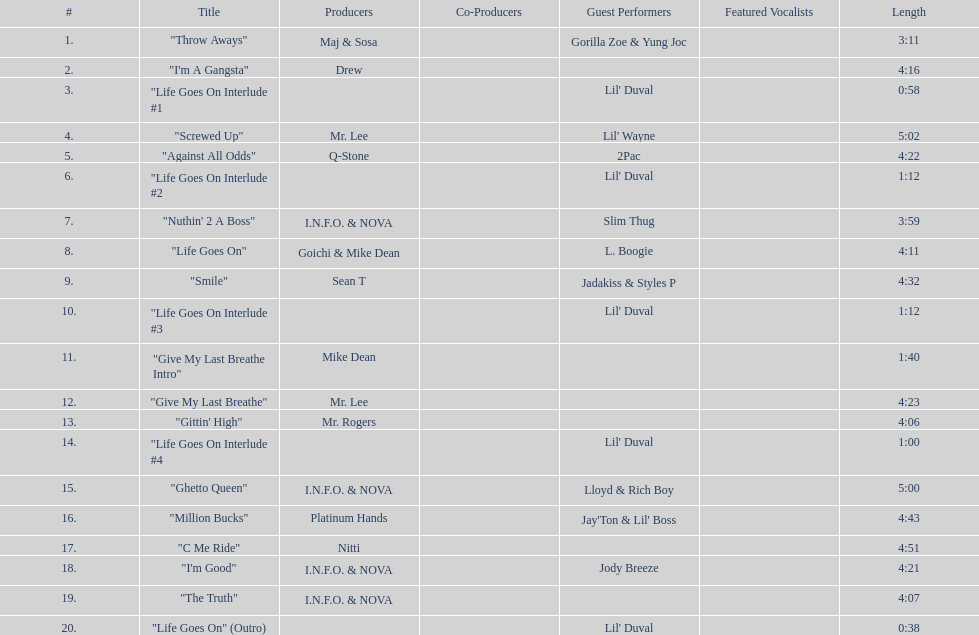I'm looking to parse the entire table for insights. Could you assist me with that? {'header': ['#', 'Title', 'Producers', 'Co-Producers', 'Guest Performers', 'Featured Vocalists', 'Length'], 'rows': [['1.', '"Throw Aways"', 'Maj & Sosa', '', 'Gorilla Zoe & Yung Joc', '', '3:11'], ['2.', '"I\'m A Gangsta"', 'Drew', '', '', '', '4:16'], ['3.', '"Life Goes On Interlude #1', '', '', "Lil' Duval", '', '0:58'], ['4.', '"Screwed Up"', 'Mr. Lee', '', "Lil' Wayne", '', '5:02'], ['5.', '"Against All Odds"', 'Q-Stone', '', '2Pac', '', '4:22'], ['6.', '"Life Goes On Interlude #2', '', '', "Lil' Duval", '', '1:12'], ['7.', '"Nuthin\' 2 A Boss"', 'I.N.F.O. & NOVA', '', 'Slim Thug', '', '3:59'], ['8.', '"Life Goes On"', 'Goichi & Mike Dean', '', 'L. Boogie', '', '4:11'], ['9.', '"Smile"', 'Sean T', '', 'Jadakiss & Styles P', '', '4:32'], ['10.', '"Life Goes On Interlude #3', '', '', "Lil' Duval", '', '1:12'], ['11.', '"Give My Last Breathe Intro"', 'Mike Dean', '', '', '', '1:40'], ['12.', '"Give My Last Breathe"', 'Mr. Lee', '', '', '', '4:23'], ['13.', '"Gittin\' High"', 'Mr. Rogers', '', '', '', '4:06'], ['14.', '"Life Goes On Interlude #4', '', '', "Lil' Duval", '', '1:00'], ['15.', '"Ghetto Queen"', 'I.N.F.O. & NOVA', '', 'Lloyd & Rich Boy', '', '5:00'], ['16.', '"Million Bucks"', 'Platinum Hands', '', "Jay'Ton & Lil' Boss", '', '4:43'], ['17.', '"C Me Ride"', 'Nitti', '', '', '', '4:51'], ['18.', '"I\'m Good"', 'I.N.F.O. & NOVA', '', 'Jody Breeze', '', '4:21'], ['19.', '"The Truth"', 'I.N.F.O. & NOVA', '', '', '', '4:07'], ['20.', '"Life Goes On" (Outro)', '', '', "Lil' Duval", '', '0:38']]} How many tracks on trae's album "life goes on"? 20. 